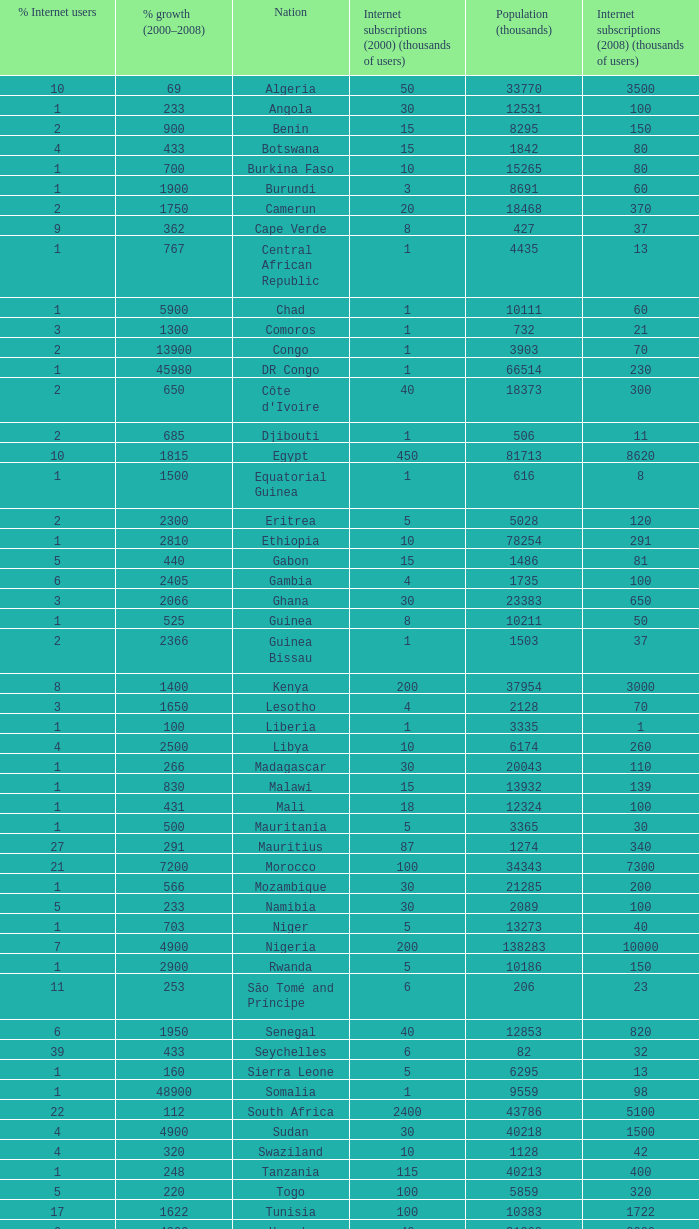Could you help me parse every detail presented in this table? {'header': ['% Internet users', '% growth (2000–2008)', 'Nation', 'Internet subscriptions (2000) (thousands of users)', 'Population (thousands)', 'Internet subscriptions (2008) (thousands of users)'], 'rows': [['10', '69', 'Algeria', '50', '33770', '3500'], ['1', '233', 'Angola', '30', '12531', '100'], ['2', '900', 'Benin', '15', '8295', '150'], ['4', '433', 'Botswana', '15', '1842', '80'], ['1', '700', 'Burkina Faso', '10', '15265', '80'], ['1', '1900', 'Burundi', '3', '8691', '60'], ['2', '1750', 'Camerun', '20', '18468', '370'], ['9', '362', 'Cape Verde', '8', '427', '37'], ['1', '767', 'Central African Republic', '1', '4435', '13'], ['1', '5900', 'Chad', '1', '10111', '60'], ['3', '1300', 'Comoros', '1', '732', '21'], ['2', '13900', 'Congo', '1', '3903', '70'], ['1', '45980', 'DR Congo', '1', '66514', '230'], ['2', '650', "Côte d'Ivoire", '40', '18373', '300'], ['2', '685', 'Djibouti', '1', '506', '11'], ['10', '1815', 'Egypt', '450', '81713', '8620'], ['1', '1500', 'Equatorial Guinea', '1', '616', '8'], ['2', '2300', 'Eritrea', '5', '5028', '120'], ['1', '2810', 'Ethiopia', '10', '78254', '291'], ['5', '440', 'Gabon', '15', '1486', '81'], ['6', '2405', 'Gambia', '4', '1735', '100'], ['3', '2066', 'Ghana', '30', '23383', '650'], ['1', '525', 'Guinea', '8', '10211', '50'], ['2', '2366', 'Guinea Bissau', '1', '1503', '37'], ['8', '1400', 'Kenya', '200', '37954', '3000'], ['3', '1650', 'Lesotho', '4', '2128', '70'], ['1', '100', 'Liberia', '1', '3335', '1'], ['4', '2500', 'Libya', '10', '6174', '260'], ['1', '266', 'Madagascar', '30', '20043', '110'], ['1', '830', 'Malawi', '15', '13932', '139'], ['1', '431', 'Mali', '18', '12324', '100'], ['1', '500', 'Mauritania', '5', '3365', '30'], ['27', '291', 'Mauritius', '87', '1274', '340'], ['21', '7200', 'Morocco', '100', '34343', '7300'], ['1', '566', 'Mozambique', '30', '21285', '200'], ['5', '233', 'Namibia', '30', '2089', '100'], ['1', '703', 'Niger', '5', '13273', '40'], ['7', '4900', 'Nigeria', '200', '138283', '10000'], ['1', '2900', 'Rwanda', '5', '10186', '150'], ['11', '253', 'São Tomé and Príncipe', '6', '206', '23'], ['6', '1950', 'Senegal', '40', '12853', '820'], ['39', '433', 'Seychelles', '6', '82', '32'], ['1', '160', 'Sierra Leone', '5', '6295', '13'], ['1', '48900', 'Somalia', '1', '9559', '98'], ['22', '112', 'South Africa', '2400', '43786', '5100'], ['4', '4900', 'Sudan', '30', '40218', '1500'], ['4', '320', 'Swaziland', '10', '1128', '42'], ['1', '248', 'Tanzania', '115', '40213', '400'], ['5', '220', 'Togo', '100', '5859', '320'], ['17', '1622', 'Tunisia', '100', '10383', '1722'], ['6', '4900', 'Uganda', '40', '31368', '2000'], ['4', '2400', 'Zambia', '20', '11669', '500'], ['11', '2602', 'Zimbabwe', '50', '12382', '1351']]} What is the maximum percentage grown 2000-2008 in burundi 1900.0. 